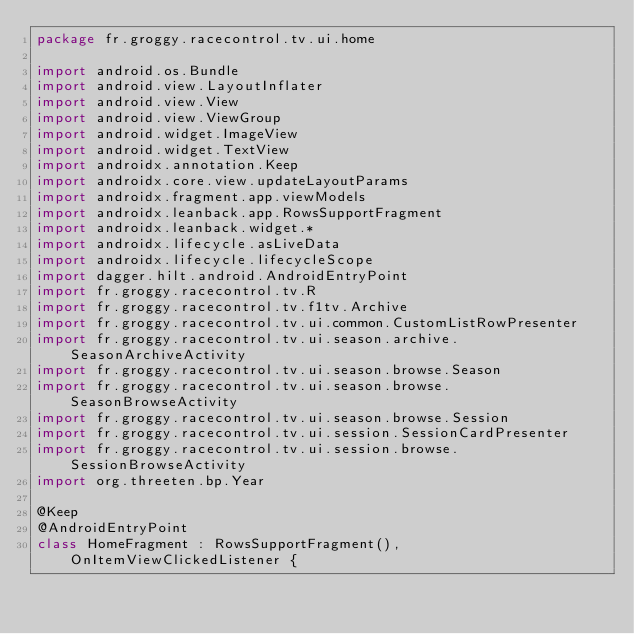<code> <loc_0><loc_0><loc_500><loc_500><_Kotlin_>package fr.groggy.racecontrol.tv.ui.home

import android.os.Bundle
import android.view.LayoutInflater
import android.view.View
import android.view.ViewGroup
import android.widget.ImageView
import android.widget.TextView
import androidx.annotation.Keep
import androidx.core.view.updateLayoutParams
import androidx.fragment.app.viewModels
import androidx.leanback.app.RowsSupportFragment
import androidx.leanback.widget.*
import androidx.lifecycle.asLiveData
import androidx.lifecycle.lifecycleScope
import dagger.hilt.android.AndroidEntryPoint
import fr.groggy.racecontrol.tv.R
import fr.groggy.racecontrol.tv.f1tv.Archive
import fr.groggy.racecontrol.tv.ui.common.CustomListRowPresenter
import fr.groggy.racecontrol.tv.ui.season.archive.SeasonArchiveActivity
import fr.groggy.racecontrol.tv.ui.season.browse.Season
import fr.groggy.racecontrol.tv.ui.season.browse.SeasonBrowseActivity
import fr.groggy.racecontrol.tv.ui.season.browse.Session
import fr.groggy.racecontrol.tv.ui.session.SessionCardPresenter
import fr.groggy.racecontrol.tv.ui.session.browse.SessionBrowseActivity
import org.threeten.bp.Year

@Keep
@AndroidEntryPoint
class HomeFragment : RowsSupportFragment(), OnItemViewClickedListener {
</code> 